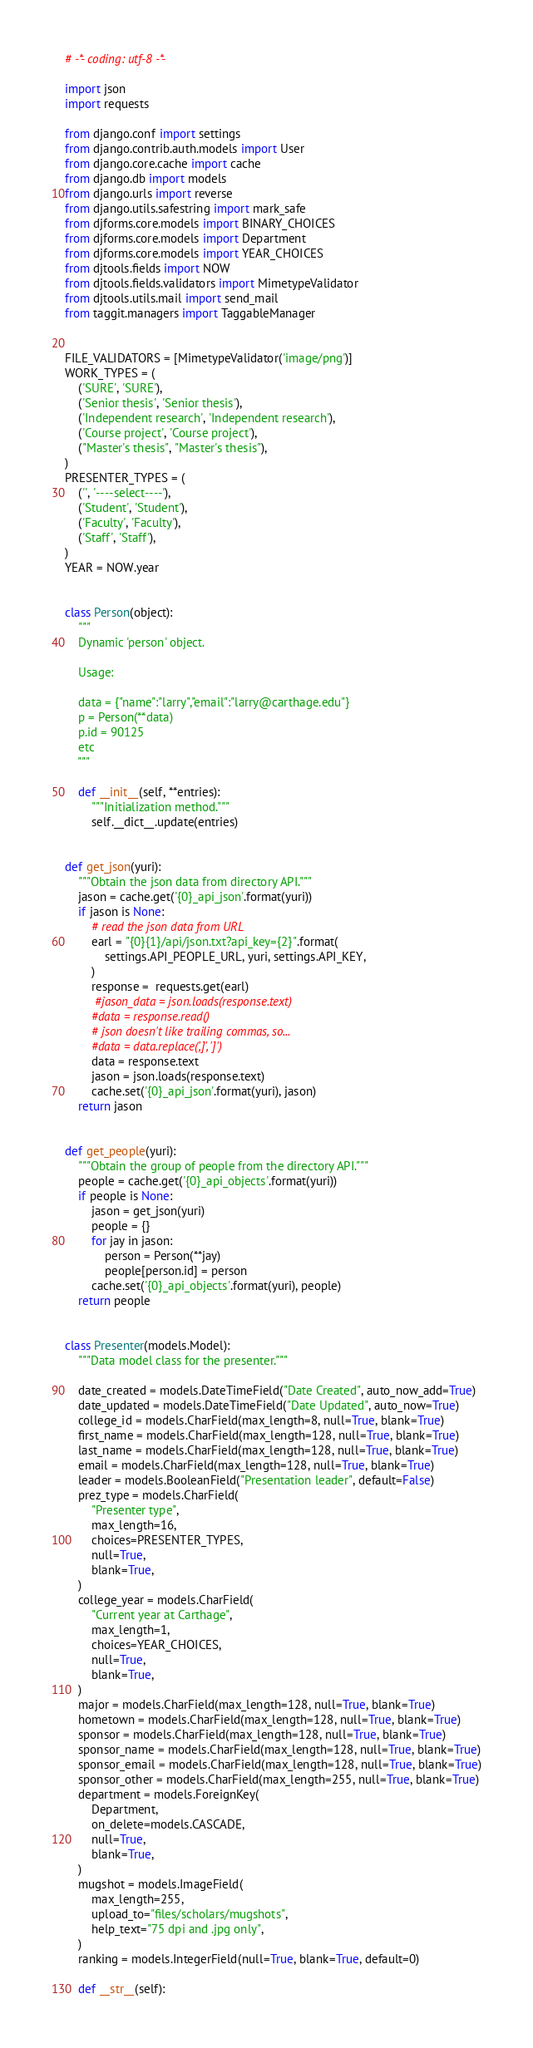<code> <loc_0><loc_0><loc_500><loc_500><_Python_># -*- coding: utf-8 -*-

import json
import requests

from django.conf import settings
from django.contrib.auth.models import User
from django.core.cache import cache
from django.db import models
from django.urls import reverse
from django.utils.safestring import mark_safe
from djforms.core.models import BINARY_CHOICES
from djforms.core.models import Department
from djforms.core.models import YEAR_CHOICES
from djtools.fields import NOW
from djtools.fields.validators import MimetypeValidator
from djtools.utils.mail import send_mail
from taggit.managers import TaggableManager


FILE_VALIDATORS = [MimetypeValidator('image/png')]
WORK_TYPES = (
    ('SURE', 'SURE'),
    ('Senior thesis', 'Senior thesis'),
    ('Independent research', 'Independent research'),
    ('Course project', 'Course project'),
    ("Master's thesis", "Master's thesis"),
)
PRESENTER_TYPES = (
    ('', '----select----'),
    ('Student', 'Student'),
    ('Faculty', 'Faculty'),
    ('Staff', 'Staff'),
)
YEAR = NOW.year


class Person(object):
    """
    Dynamic 'person' object.

    Usage:

    data = {"name":"larry","email":"larry@carthage.edu"}
    p = Person(**data)
    p.id = 90125
    etc
    """

    def __init__(self, **entries):
        """Initialization method."""
        self.__dict__.update(entries)


def get_json(yuri):
    """Obtain the json data from directory API."""
    jason = cache.get('{0}_api_json'.format(yuri))
    if jason is None:
        # read the json data from URL
        earl = "{0}{1}/api/json.txt?api_key={2}".format(
            settings.API_PEOPLE_URL, yuri, settings.API_KEY,
        )
        response =  requests.get(earl)
         #jason_data = json.loads(response.text)
        #data = response.read()
        # json doesn't like trailing commas, so...
        #data = data.replace(',]', ']')
        data = response.text
        jason = json.loads(response.text)
        cache.set('{0}_api_json'.format(yuri), jason)
    return jason


def get_people(yuri):
    """Obtain the group of people from the directory API."""
    people = cache.get('{0}_api_objects'.format(yuri))
    if people is None:
        jason = get_json(yuri)
        people = {}
        for jay in jason:
            person = Person(**jay)
            people[person.id] = person
        cache.set('{0}_api_objects'.format(yuri), people)
    return people


class Presenter(models.Model):
    """Data model class for the presenter."""

    date_created = models.DateTimeField("Date Created", auto_now_add=True)
    date_updated = models.DateTimeField("Date Updated", auto_now=True)
    college_id = models.CharField(max_length=8, null=True, blank=True)
    first_name = models.CharField(max_length=128, null=True, blank=True)
    last_name = models.CharField(max_length=128, null=True, blank=True)
    email = models.CharField(max_length=128, null=True, blank=True)
    leader = models.BooleanField("Presentation leader", default=False)
    prez_type = models.CharField(
        "Presenter type",
        max_length=16,
        choices=PRESENTER_TYPES,
        null=True,
        blank=True,
    )
    college_year = models.CharField(
        "Current year at Carthage",
        max_length=1,
        choices=YEAR_CHOICES,
        null=True,
        blank=True,
    )
    major = models.CharField(max_length=128, null=True, blank=True)
    hometown = models.CharField(max_length=128, null=True, blank=True)
    sponsor = models.CharField(max_length=128, null=True, blank=True)
    sponsor_name = models.CharField(max_length=128, null=True, blank=True)
    sponsor_email = models.CharField(max_length=128, null=True, blank=True)
    sponsor_other = models.CharField(max_length=255, null=True, blank=True)
    department = models.ForeignKey(
        Department,
        on_delete=models.CASCADE,
        null=True,
        blank=True,
    )
    mugshot = models.ImageField(
        max_length=255,
        upload_to="files/scholars/mugshots",
        help_text="75 dpi and .jpg only",
    )
    ranking = models.IntegerField(null=True, blank=True, default=0)

    def __str__(self):</code> 